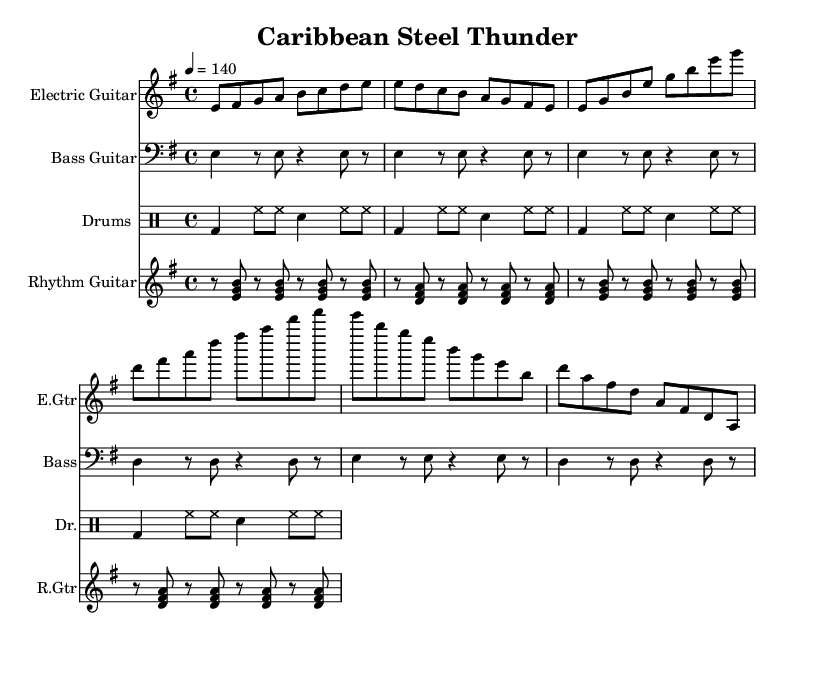What is the key signature of this music? The key signature is indicated at the beginning of the staff, with one sharp, which corresponds to E minor.
Answer: E minor What is the time signature of this piece? The time signature is displayed at the beginning of the score, which shows four beats per measure, indicated as 4/4.
Answer: 4/4 What is the tempo marking in this score? The tempo marking indicates the speed of the piece, which is set at a quarter note equals 140 beats per minute.
Answer: 140 How many measures does the introduction have? The introduction consists of a series of eight notes over two measures, which can be counted directly from the music sheet as two measures.
Answer: 2 What rhythmic pattern is used in the drums part? The drums part follows a basic rock beat pattern throughout the music, characterized by a bass drum on beats 1 and 3 and snare hits on beats 2 and 4.
Answer: Basic rock beat What kind of guitar technique is reflected in the rhythm guitar section? The rhythm guitar section demonstrates a ska-influenced upstroke technique where chord hits are emphasized on offbeats, creating a distinctive rhythmic feel.
Answer: Ska-influenced upstrokes Which Afro-Caribbean element is present in the piece? The piece incorporates a reggae feel, which is evident in the syncopated rhythms and offbeat accents found in both the rhythm and bass guitar parts.
Answer: Reggae feel 